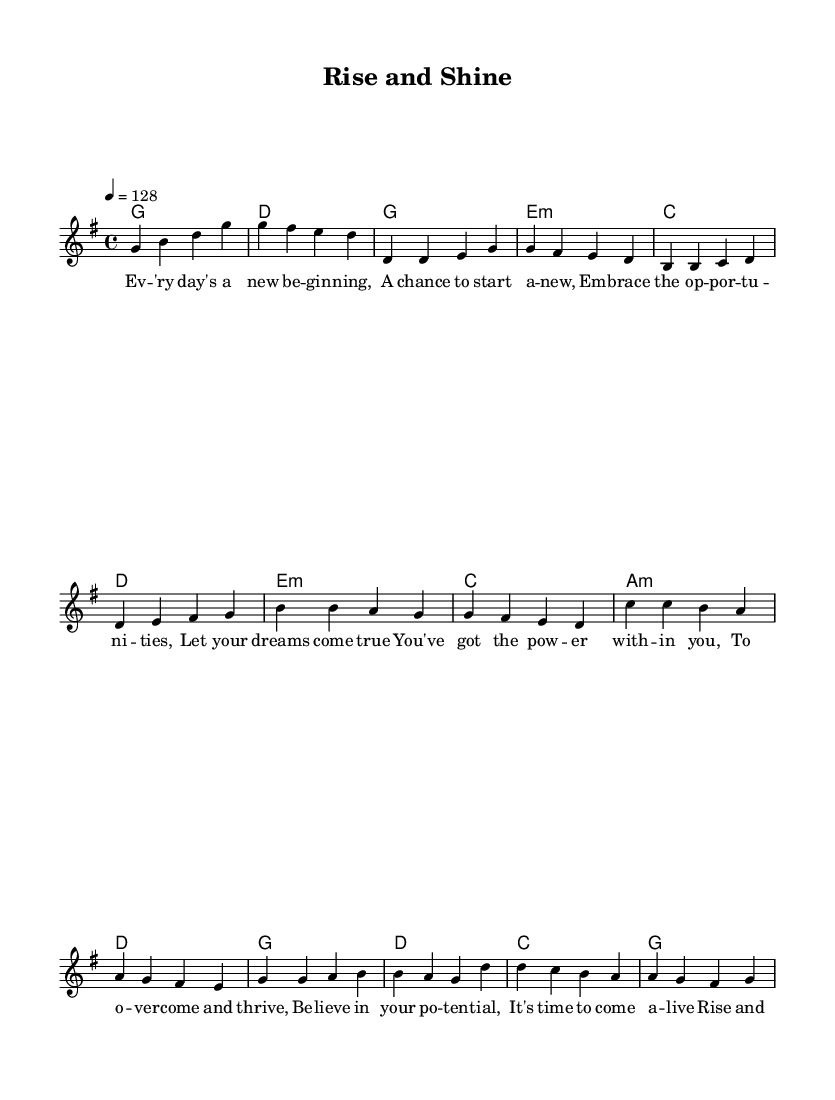What is the key signature of this music? The key signature is G major, which contains one sharp (F#). This can be determined by examining the key signature indicated at the beginning of the score.
Answer: G major What is the time signature of this piece? The time signature is 4/4, as indicated at the beginning of the score. In 4/4 time, there are four beats per measure, and each quarter note gets one beat.
Answer: 4/4 What is the tempo of the music? The tempo is indicated as 128 beats per minute, which is expressed at the beginning of the score and dictates how fast the music should be played.
Answer: 128 How many measures are there in the chorus? There are four measures in the chorus, which can be counted by examining the section labeled as the chorus in the score. Each set of four beats represents a measure.
Answer: 4 What emotional theme is present in the lyrics? The emotional theme of the lyrics revolves around positivity and empowerment, as it encourages individuals to believe in themselves and pursue their dreams, making it suitable for a motivational K-Pop song. This is evident in the lyrics’ content which emphasizes personal growth.
Answer: Positivity Which musical technique is employed in the pre-chorus section? The pre-chorus uses a repeated melodic pattern to build interest and prepare for the chorus, which is a common technique in K-Pop to enhance the emotional buildup towards the more impactful chorus. This repetition creates anticipation for the following section.
Answer: Repetition 